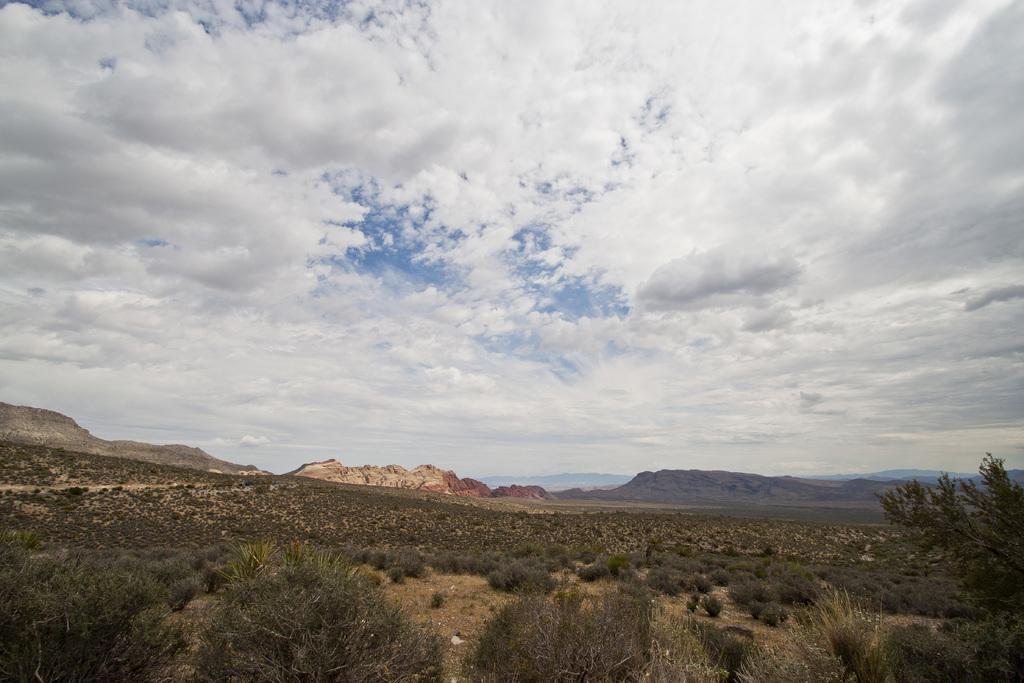How would you summarize this image in a sentence or two? In this picture we can see plants, tree, hills and a cloudy sky. 